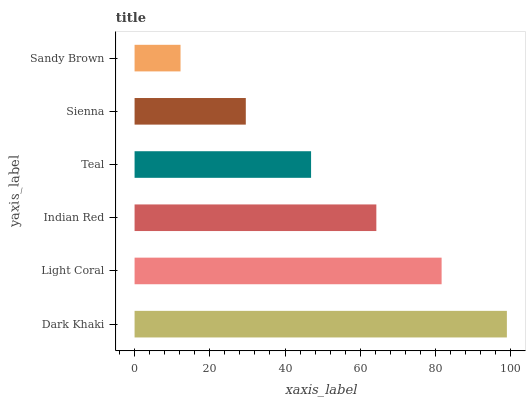Is Sandy Brown the minimum?
Answer yes or no. Yes. Is Dark Khaki the maximum?
Answer yes or no. Yes. Is Light Coral the minimum?
Answer yes or no. No. Is Light Coral the maximum?
Answer yes or no. No. Is Dark Khaki greater than Light Coral?
Answer yes or no. Yes. Is Light Coral less than Dark Khaki?
Answer yes or no. Yes. Is Light Coral greater than Dark Khaki?
Answer yes or no. No. Is Dark Khaki less than Light Coral?
Answer yes or no. No. Is Indian Red the high median?
Answer yes or no. Yes. Is Teal the low median?
Answer yes or no. Yes. Is Sandy Brown the high median?
Answer yes or no. No. Is Sandy Brown the low median?
Answer yes or no. No. 